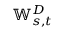<formula> <loc_0><loc_0><loc_500><loc_500>\mathbb { W } _ { s , t } ^ { D }</formula> 